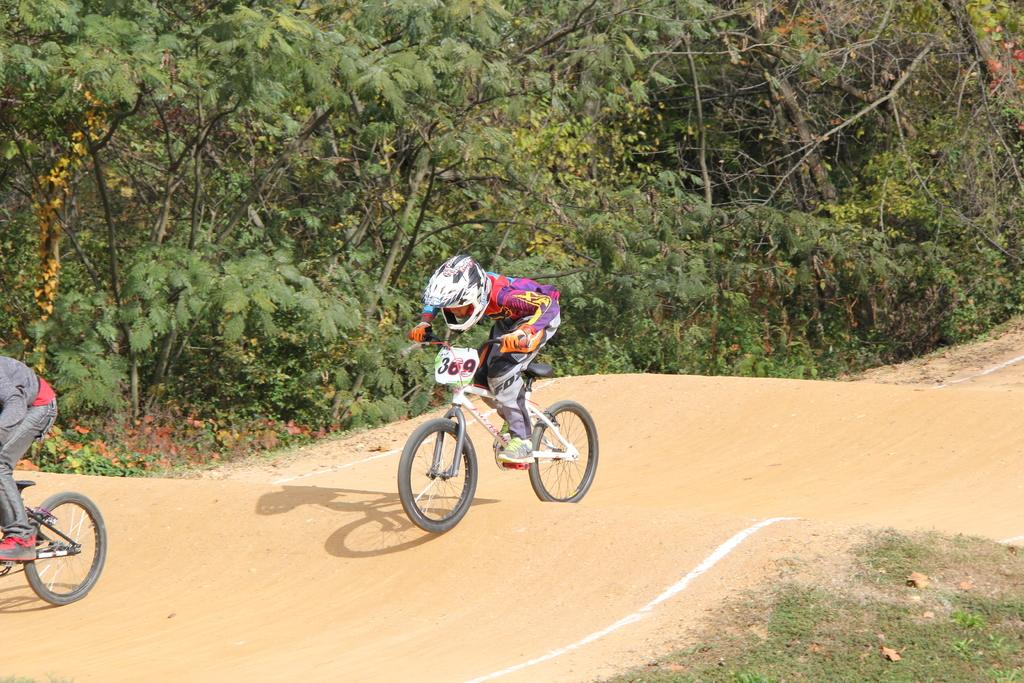What are the people in the image doing? The people in the image are riding bicycles. What can be seen in the background of the image? There are trees visible in the image. What safety gear is one person wearing in the image? One person is wearing a helmet on their head. What protective gear is another person wearing in the image? One person is wearing gloves on their hands. What type of cakes are being served in the afternoon at the coast in the image? There are no cakes, afternoon, or coast present in the image; it features people riding bicycles with a background of trees. 